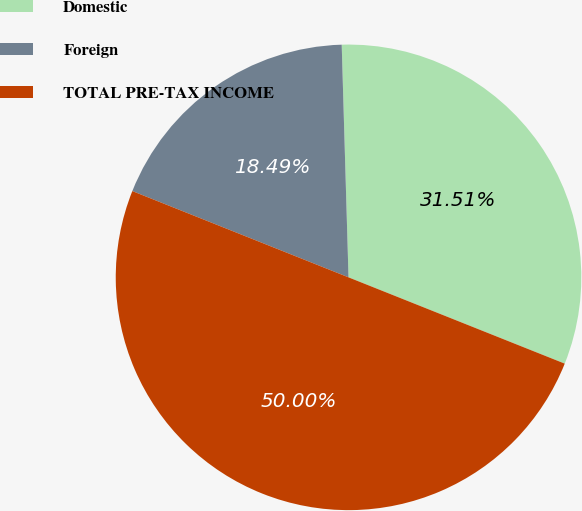<chart> <loc_0><loc_0><loc_500><loc_500><pie_chart><fcel>Domestic<fcel>Foreign<fcel>TOTAL PRE-TAX INCOME<nl><fcel>31.51%<fcel>18.49%<fcel>50.0%<nl></chart> 